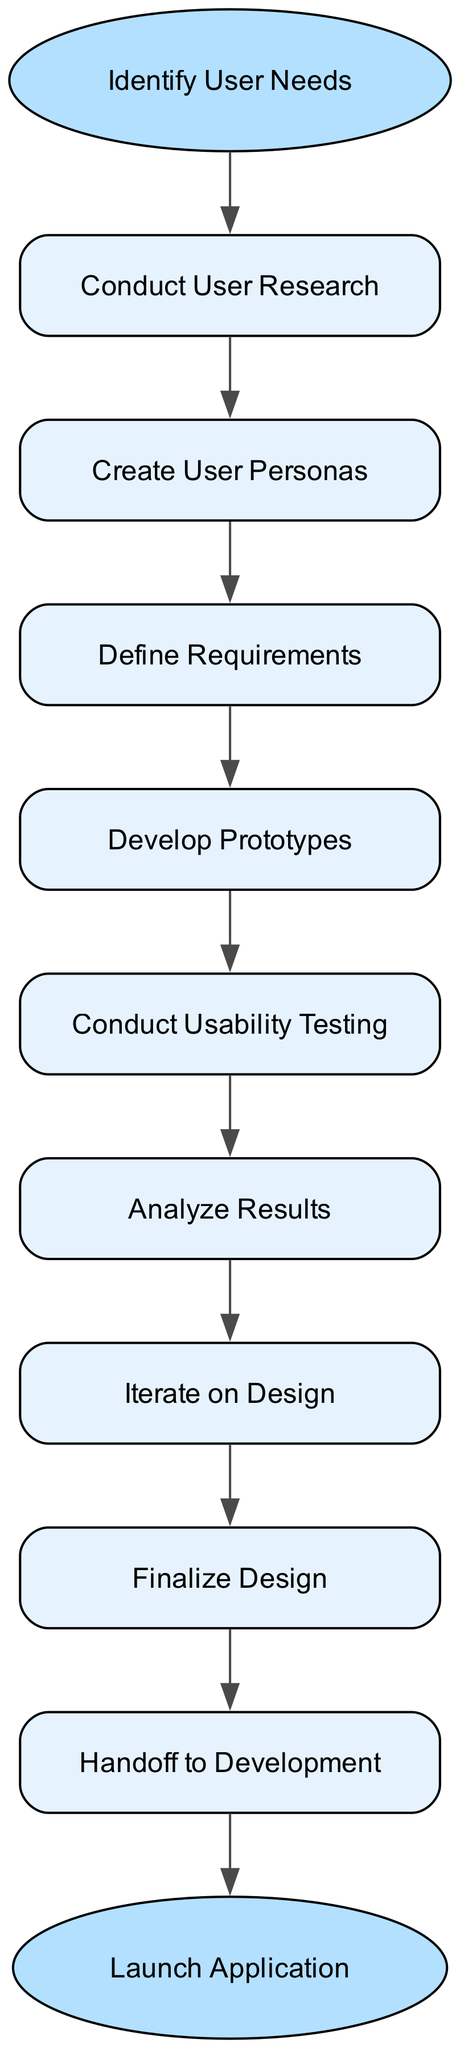What is the starting point of the process? The starting point of the process is labeled as "Identify User Needs." This is the node from which the flowchart begins and connects to the first step in the design process.
Answer: Identify User Needs How many steps are there in the process? To find the number of steps, we can count the nodes listed in the "steps" field in the data. There are 8 steps leading from the start to the end of the process.
Answer: 8 What is the final step before launching the application? The final step before the application is launched is labeled "Handoff to Development." This is the last action that occurs in the flowchart before reaching the end node.
Answer: Handoff to Development Which step comes after conducting usability testing? After "Conduct Usability Testing," the next step is "Analyze Results." This is the sequential flow as defined in the steps of the diagram.
Answer: Analyze Results What is the relationship between "Create User Personas" and "Define Requirements"? "Create User Personas" leads directly to "Define Requirements." This means that the completion of the first step is necessary before moving on to the next.
Answer: Leads directly to What is the last action in the process? The last action in the process, according to the flowchart, is "Handoff to Development," which indicates that after finalizing design, the project transitions to the development team.
Answer: Handoff to Development How does the process flow from developing prototypes? After "Develop Prototypes," the process flows to "Conduct Usability Testing." This indicates that once prototypes are developed, usability testing is the subsequent focus.
Answer: Conduct Usability Testing What step directly follows analyzing results? "Iterate on Design" follows directly after "Analyze Results" in the sequence of the design process, indicating that analysis leads to improvements in the design.
Answer: Iterate on Design 